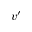Convert formula to latex. <formula><loc_0><loc_0><loc_500><loc_500>v ^ { \prime }</formula> 